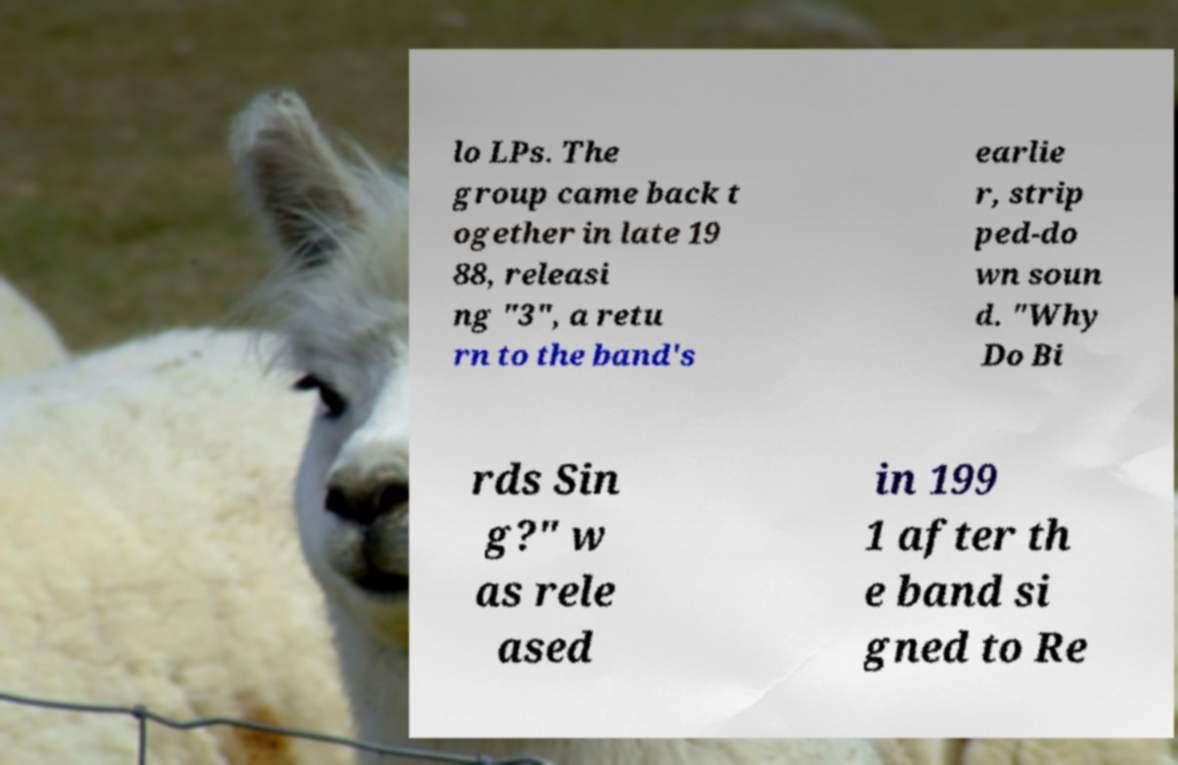For documentation purposes, I need the text within this image transcribed. Could you provide that? lo LPs. The group came back t ogether in late 19 88, releasi ng "3", a retu rn to the band's earlie r, strip ped-do wn soun d. "Why Do Bi rds Sin g?" w as rele ased in 199 1 after th e band si gned to Re 